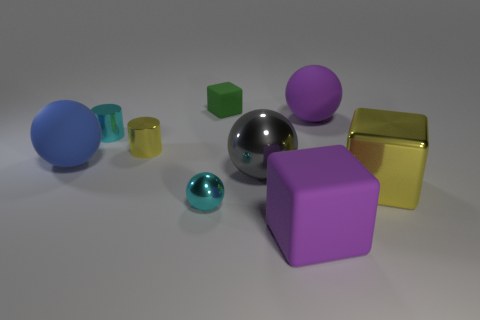Are there any large brown objects that have the same shape as the tiny yellow object?
Your answer should be compact. No. The rubber object that is the same size as the cyan metal ball is what shape?
Your answer should be very brief. Cube. What number of small cylinders are the same color as the small shiny ball?
Provide a short and direct response. 1. What size is the cyan thing in front of the yellow cube?
Your answer should be very brief. Small. How many shiny blocks have the same size as the green thing?
Offer a very short reply. 0. There is a cube that is the same material as the big gray ball; what is its color?
Your answer should be very brief. Yellow. Is the number of big shiny blocks to the right of the big yellow metallic cube less than the number of yellow metal objects?
Your answer should be compact. Yes. There is a blue thing that is the same material as the small block; what shape is it?
Make the answer very short. Sphere. What number of metal things are either purple balls or green blocks?
Keep it short and to the point. 0. Are there the same number of small cyan shiny balls behind the green thing and large rubber objects?
Provide a short and direct response. No. 